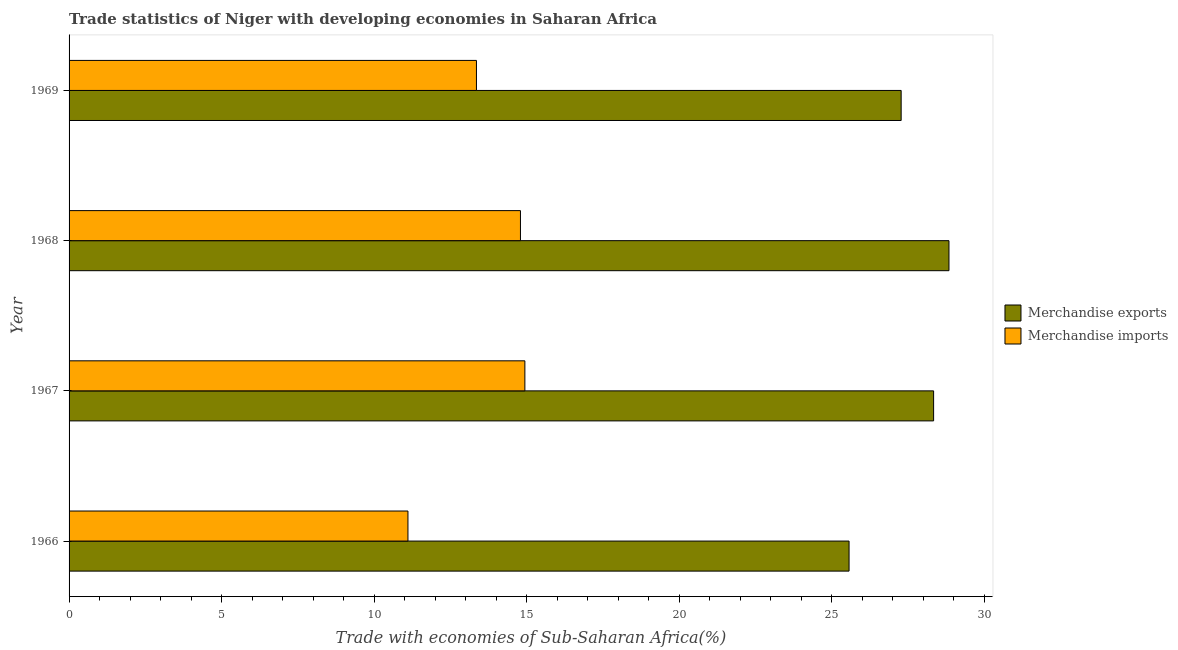How many different coloured bars are there?
Ensure brevity in your answer.  2. How many groups of bars are there?
Your answer should be very brief. 4. How many bars are there on the 4th tick from the top?
Provide a short and direct response. 2. How many bars are there on the 2nd tick from the bottom?
Your response must be concise. 2. What is the label of the 4th group of bars from the top?
Offer a very short reply. 1966. What is the merchandise imports in 1968?
Offer a terse response. 14.8. Across all years, what is the maximum merchandise exports?
Provide a short and direct response. 28.85. Across all years, what is the minimum merchandise imports?
Provide a short and direct response. 11.11. In which year was the merchandise exports maximum?
Provide a short and direct response. 1968. In which year was the merchandise imports minimum?
Provide a short and direct response. 1966. What is the total merchandise exports in the graph?
Your answer should be compact. 110.05. What is the difference between the merchandise exports in 1967 and that in 1968?
Offer a very short reply. -0.5. What is the difference between the merchandise exports in 1968 and the merchandise imports in 1969?
Your response must be concise. 15.49. What is the average merchandise exports per year?
Keep it short and to the point. 27.51. In the year 1967, what is the difference between the merchandise exports and merchandise imports?
Provide a short and direct response. 13.4. What is the ratio of the merchandise exports in 1967 to that in 1969?
Give a very brief answer. 1.04. Is the merchandise exports in 1967 less than that in 1969?
Your answer should be compact. No. Is the difference between the merchandise exports in 1966 and 1968 greater than the difference between the merchandise imports in 1966 and 1968?
Offer a terse response. Yes. What is the difference between the highest and the second highest merchandise exports?
Your answer should be very brief. 0.5. What is the difference between the highest and the lowest merchandise imports?
Offer a very short reply. 3.83. In how many years, is the merchandise exports greater than the average merchandise exports taken over all years?
Keep it short and to the point. 2. Is the sum of the merchandise imports in 1967 and 1968 greater than the maximum merchandise exports across all years?
Your answer should be very brief. Yes. What does the 1st bar from the bottom in 1969 represents?
Give a very brief answer. Merchandise exports. What is the difference between two consecutive major ticks on the X-axis?
Keep it short and to the point. 5. Are the values on the major ticks of X-axis written in scientific E-notation?
Give a very brief answer. No. How are the legend labels stacked?
Provide a short and direct response. Vertical. What is the title of the graph?
Provide a succinct answer. Trade statistics of Niger with developing economies in Saharan Africa. Does "Travel Items" appear as one of the legend labels in the graph?
Your response must be concise. No. What is the label or title of the X-axis?
Make the answer very short. Trade with economies of Sub-Saharan Africa(%). What is the label or title of the Y-axis?
Provide a succinct answer. Year. What is the Trade with economies of Sub-Saharan Africa(%) in Merchandise exports in 1966?
Give a very brief answer. 25.57. What is the Trade with economies of Sub-Saharan Africa(%) in Merchandise imports in 1966?
Give a very brief answer. 11.11. What is the Trade with economies of Sub-Saharan Africa(%) in Merchandise exports in 1967?
Keep it short and to the point. 28.35. What is the Trade with economies of Sub-Saharan Africa(%) in Merchandise imports in 1967?
Your response must be concise. 14.95. What is the Trade with economies of Sub-Saharan Africa(%) of Merchandise exports in 1968?
Your answer should be very brief. 28.85. What is the Trade with economies of Sub-Saharan Africa(%) of Merchandise imports in 1968?
Your response must be concise. 14.8. What is the Trade with economies of Sub-Saharan Africa(%) in Merchandise exports in 1969?
Your answer should be compact. 27.28. What is the Trade with economies of Sub-Saharan Africa(%) in Merchandise imports in 1969?
Provide a succinct answer. 13.36. Across all years, what is the maximum Trade with economies of Sub-Saharan Africa(%) in Merchandise exports?
Your answer should be very brief. 28.85. Across all years, what is the maximum Trade with economies of Sub-Saharan Africa(%) in Merchandise imports?
Provide a succinct answer. 14.95. Across all years, what is the minimum Trade with economies of Sub-Saharan Africa(%) in Merchandise exports?
Your response must be concise. 25.57. Across all years, what is the minimum Trade with economies of Sub-Saharan Africa(%) of Merchandise imports?
Ensure brevity in your answer.  11.11. What is the total Trade with economies of Sub-Saharan Africa(%) in Merchandise exports in the graph?
Your answer should be very brief. 110.05. What is the total Trade with economies of Sub-Saharan Africa(%) of Merchandise imports in the graph?
Make the answer very short. 54.21. What is the difference between the Trade with economies of Sub-Saharan Africa(%) of Merchandise exports in 1966 and that in 1967?
Offer a terse response. -2.77. What is the difference between the Trade with economies of Sub-Saharan Africa(%) in Merchandise imports in 1966 and that in 1967?
Provide a short and direct response. -3.83. What is the difference between the Trade with economies of Sub-Saharan Africa(%) of Merchandise exports in 1966 and that in 1968?
Your answer should be very brief. -3.28. What is the difference between the Trade with economies of Sub-Saharan Africa(%) in Merchandise imports in 1966 and that in 1968?
Ensure brevity in your answer.  -3.69. What is the difference between the Trade with economies of Sub-Saharan Africa(%) of Merchandise exports in 1966 and that in 1969?
Your answer should be compact. -1.71. What is the difference between the Trade with economies of Sub-Saharan Africa(%) of Merchandise imports in 1966 and that in 1969?
Your response must be concise. -2.25. What is the difference between the Trade with economies of Sub-Saharan Africa(%) of Merchandise exports in 1967 and that in 1968?
Offer a very short reply. -0.5. What is the difference between the Trade with economies of Sub-Saharan Africa(%) of Merchandise imports in 1967 and that in 1968?
Your response must be concise. 0.14. What is the difference between the Trade with economies of Sub-Saharan Africa(%) in Merchandise exports in 1967 and that in 1969?
Provide a succinct answer. 1.06. What is the difference between the Trade with economies of Sub-Saharan Africa(%) of Merchandise imports in 1967 and that in 1969?
Provide a short and direct response. 1.59. What is the difference between the Trade with economies of Sub-Saharan Africa(%) in Merchandise exports in 1968 and that in 1969?
Make the answer very short. 1.57. What is the difference between the Trade with economies of Sub-Saharan Africa(%) in Merchandise imports in 1968 and that in 1969?
Make the answer very short. 1.44. What is the difference between the Trade with economies of Sub-Saharan Africa(%) of Merchandise exports in 1966 and the Trade with economies of Sub-Saharan Africa(%) of Merchandise imports in 1967?
Make the answer very short. 10.63. What is the difference between the Trade with economies of Sub-Saharan Africa(%) in Merchandise exports in 1966 and the Trade with economies of Sub-Saharan Africa(%) in Merchandise imports in 1968?
Offer a very short reply. 10.77. What is the difference between the Trade with economies of Sub-Saharan Africa(%) in Merchandise exports in 1966 and the Trade with economies of Sub-Saharan Africa(%) in Merchandise imports in 1969?
Keep it short and to the point. 12.22. What is the difference between the Trade with economies of Sub-Saharan Africa(%) of Merchandise exports in 1967 and the Trade with economies of Sub-Saharan Africa(%) of Merchandise imports in 1968?
Provide a short and direct response. 13.55. What is the difference between the Trade with economies of Sub-Saharan Africa(%) in Merchandise exports in 1967 and the Trade with economies of Sub-Saharan Africa(%) in Merchandise imports in 1969?
Offer a terse response. 14.99. What is the difference between the Trade with economies of Sub-Saharan Africa(%) in Merchandise exports in 1968 and the Trade with economies of Sub-Saharan Africa(%) in Merchandise imports in 1969?
Your response must be concise. 15.49. What is the average Trade with economies of Sub-Saharan Africa(%) of Merchandise exports per year?
Make the answer very short. 27.51. What is the average Trade with economies of Sub-Saharan Africa(%) in Merchandise imports per year?
Make the answer very short. 13.55. In the year 1966, what is the difference between the Trade with economies of Sub-Saharan Africa(%) in Merchandise exports and Trade with economies of Sub-Saharan Africa(%) in Merchandise imports?
Your answer should be compact. 14.46. In the year 1967, what is the difference between the Trade with economies of Sub-Saharan Africa(%) of Merchandise exports and Trade with economies of Sub-Saharan Africa(%) of Merchandise imports?
Provide a short and direct response. 13.4. In the year 1968, what is the difference between the Trade with economies of Sub-Saharan Africa(%) of Merchandise exports and Trade with economies of Sub-Saharan Africa(%) of Merchandise imports?
Ensure brevity in your answer.  14.05. In the year 1969, what is the difference between the Trade with economies of Sub-Saharan Africa(%) of Merchandise exports and Trade with economies of Sub-Saharan Africa(%) of Merchandise imports?
Your answer should be compact. 13.93. What is the ratio of the Trade with economies of Sub-Saharan Africa(%) in Merchandise exports in 1966 to that in 1967?
Provide a short and direct response. 0.9. What is the ratio of the Trade with economies of Sub-Saharan Africa(%) of Merchandise imports in 1966 to that in 1967?
Give a very brief answer. 0.74. What is the ratio of the Trade with economies of Sub-Saharan Africa(%) of Merchandise exports in 1966 to that in 1968?
Offer a terse response. 0.89. What is the ratio of the Trade with economies of Sub-Saharan Africa(%) in Merchandise imports in 1966 to that in 1968?
Your answer should be very brief. 0.75. What is the ratio of the Trade with economies of Sub-Saharan Africa(%) of Merchandise exports in 1966 to that in 1969?
Offer a terse response. 0.94. What is the ratio of the Trade with economies of Sub-Saharan Africa(%) in Merchandise imports in 1966 to that in 1969?
Ensure brevity in your answer.  0.83. What is the ratio of the Trade with economies of Sub-Saharan Africa(%) of Merchandise exports in 1967 to that in 1968?
Provide a succinct answer. 0.98. What is the ratio of the Trade with economies of Sub-Saharan Africa(%) of Merchandise imports in 1967 to that in 1968?
Your answer should be very brief. 1.01. What is the ratio of the Trade with economies of Sub-Saharan Africa(%) in Merchandise exports in 1967 to that in 1969?
Make the answer very short. 1.04. What is the ratio of the Trade with economies of Sub-Saharan Africa(%) in Merchandise imports in 1967 to that in 1969?
Offer a very short reply. 1.12. What is the ratio of the Trade with economies of Sub-Saharan Africa(%) of Merchandise exports in 1968 to that in 1969?
Provide a succinct answer. 1.06. What is the ratio of the Trade with economies of Sub-Saharan Africa(%) in Merchandise imports in 1968 to that in 1969?
Provide a succinct answer. 1.11. What is the difference between the highest and the second highest Trade with economies of Sub-Saharan Africa(%) in Merchandise exports?
Offer a terse response. 0.5. What is the difference between the highest and the second highest Trade with economies of Sub-Saharan Africa(%) of Merchandise imports?
Provide a succinct answer. 0.14. What is the difference between the highest and the lowest Trade with economies of Sub-Saharan Africa(%) of Merchandise exports?
Your response must be concise. 3.28. What is the difference between the highest and the lowest Trade with economies of Sub-Saharan Africa(%) in Merchandise imports?
Offer a terse response. 3.83. 